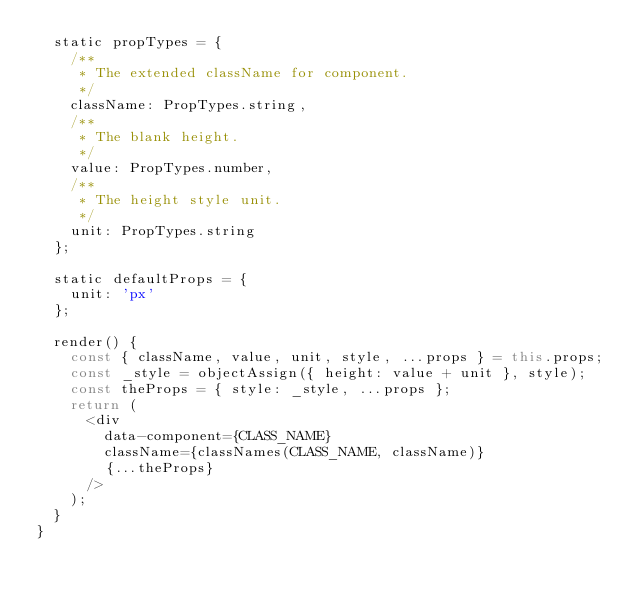Convert code to text. <code><loc_0><loc_0><loc_500><loc_500><_JavaScript_>  static propTypes = {
    /**
     * The extended className for component.
     */
    className: PropTypes.string,
    /**
     * The blank height.
     */
    value: PropTypes.number,
    /**
     * The height style unit.
     */
    unit: PropTypes.string
  };

  static defaultProps = {
    unit: 'px'
  };

  render() {
    const { className, value, unit, style, ...props } = this.props;
    const _style = objectAssign({ height: value + unit }, style);
    const theProps = { style: _style, ...props };
    return (
      <div
        data-component={CLASS_NAME}
        className={classNames(CLASS_NAME, className)}
        {...theProps}
      />
    );
  }
}
</code> 